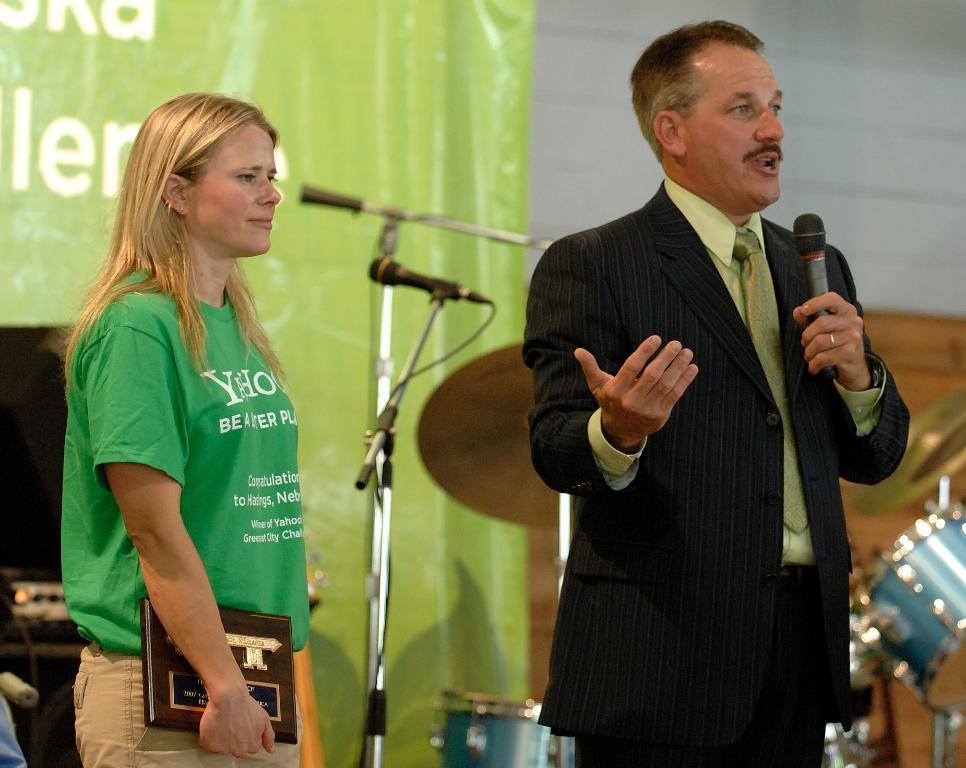Who are the people in the image? There is a woman and a man in the image. What is the man holding in the image? The man is holding a mic. What is the woman holding in the image? The woman is holding a book. What other musical equipment can be seen in the background of the image? There are additional mics and a drum set in the background of the image. What type of cherry is the woman eating in the image? There is no cherry present in the image; the woman is holding a book. What role does the manager play in the image? There is no mention of a manager in the image or the provided facts. 